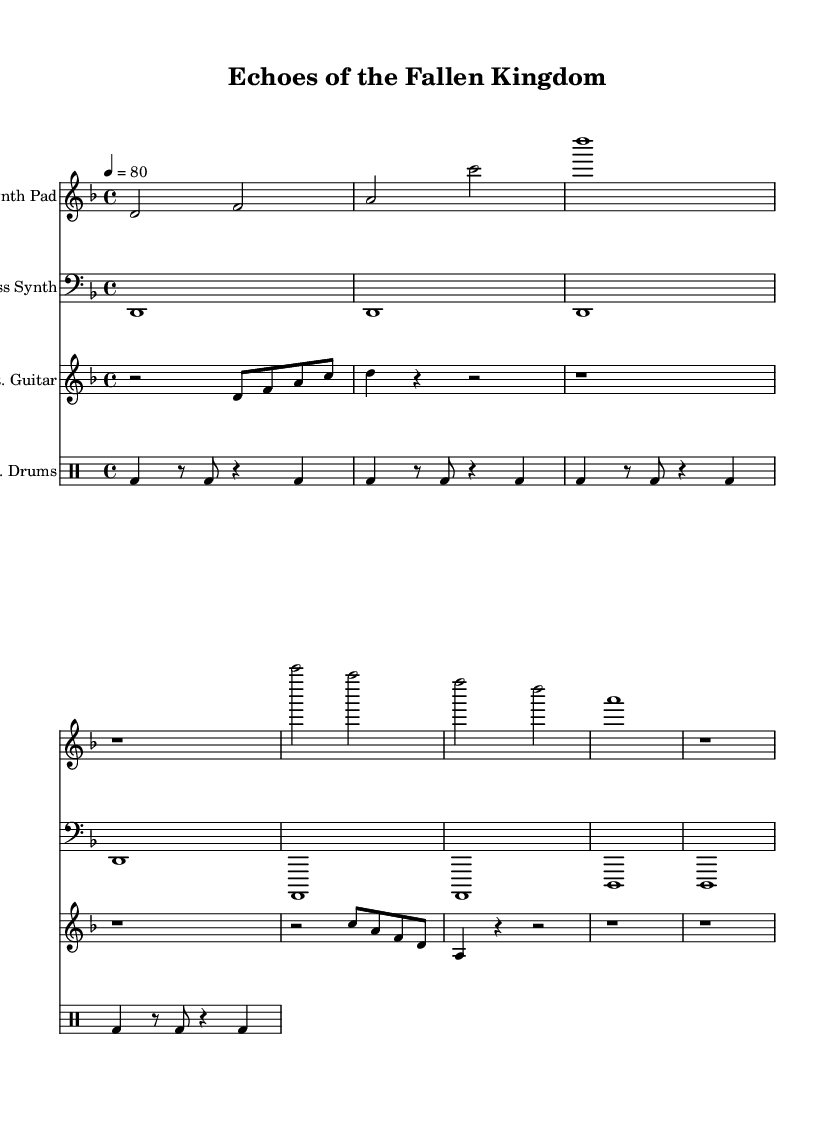What is the key signature of this music? The key signature is D minor, indicated by one flat in the key signature section of the music sheet.
Answer: D minor What is the time signature of this music? The time signature is 4/4, shown at the beginning of the score with four beats in each measure and the quarter note receiving one beat.
Answer: 4/4 What is the tempo marking of this piece? The tempo marking indicates a speed of 80 beats per minute, written as "4 = 80" in the score, which gives a specific instruction on how quickly to play.
Answer: 80 How many distinct instrument parts are there in this score? There are four distinct parts: Synth Pad, Bass Synth, Distorted Guitar, and Electronic Drums, each represented by its own staff, clearly labeled at the beginning of each part.
Answer: Four Which instrument plays sustained chords throughout most of the piece? The Synth Pad plays sustained chords primarily, as indicated by the whole notes and longer durations throughout the staff, creating an ambient soundscape.
Answer: Synth Pad How does the rhythm of the electronic drums contribute to the overall sound? The rhythm is consistent with a repetitive bass drum pattern, creating a driving force at a steady pace that supports the ambient textures of the other instruments.
Answer: Driving force What unique feature is present in the distorted guitar part? The distorted guitar features rests and rhythmic variation that introduce unpredictability and a metal edge to the ambient soundscape, making it stand out.
Answer: Rhythmic variation 